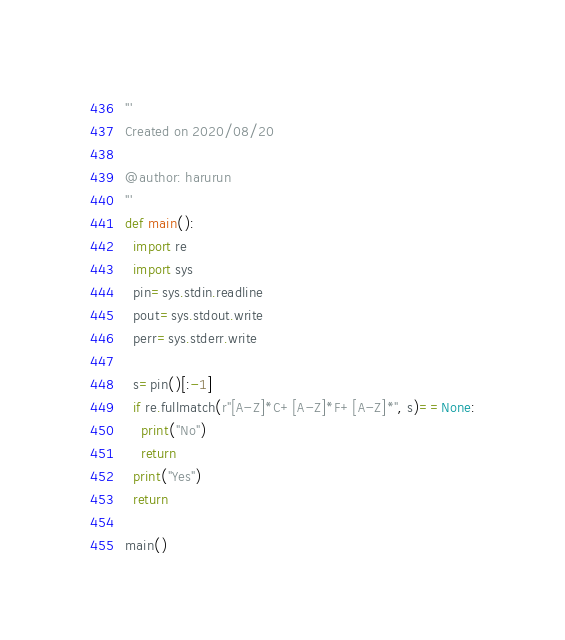<code> <loc_0><loc_0><loc_500><loc_500><_Python_>'''
Created on 2020/08/20

@author: harurun
'''
def main():
  import re
  import sys
  pin=sys.stdin.readline
  pout=sys.stdout.write
  perr=sys.stderr.write

  s=pin()[:-1]
  if re.fullmatch(r"[A-Z]*C+[A-Z]*F+[A-Z]*", s)==None:
    print("No")
    return
  print("Yes")
  return

main()</code> 